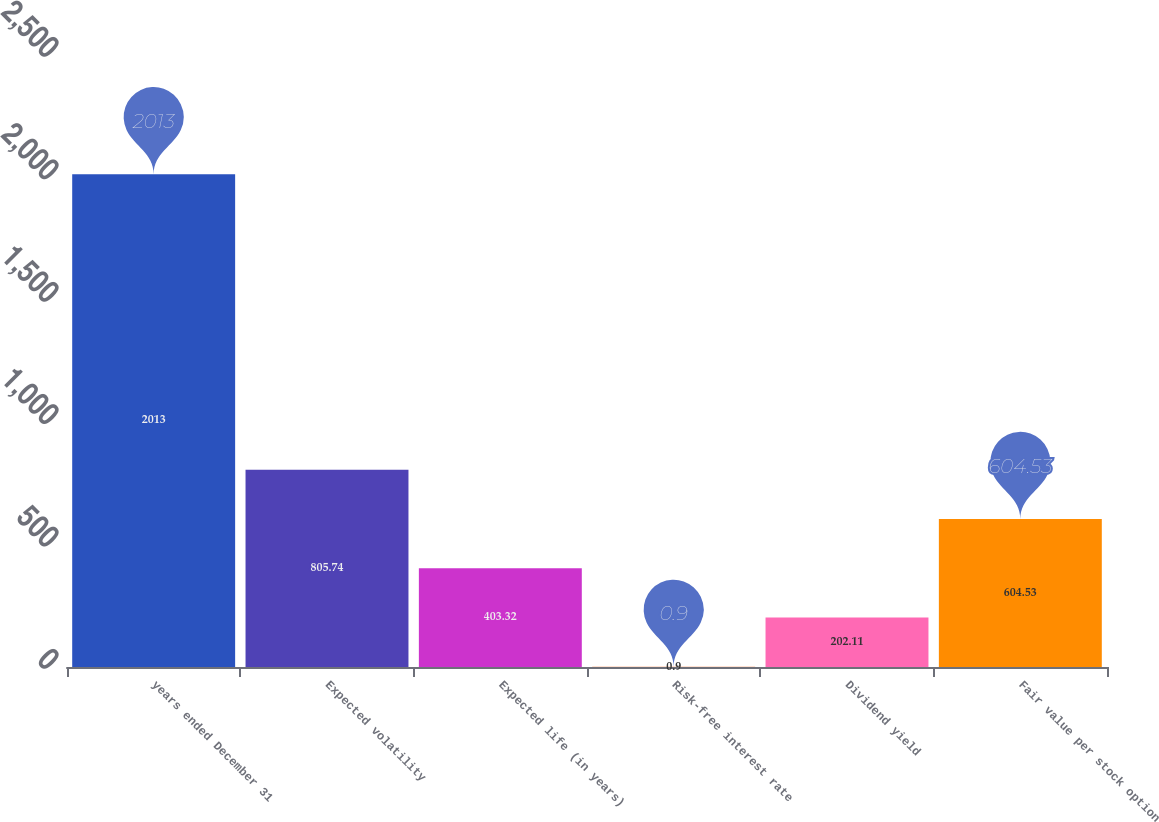Convert chart to OTSL. <chart><loc_0><loc_0><loc_500><loc_500><bar_chart><fcel>years ended December 31<fcel>Expected volatility<fcel>Expected life (in years)<fcel>Risk-free interest rate<fcel>Dividend yield<fcel>Fair value per stock option<nl><fcel>2013<fcel>805.74<fcel>403.32<fcel>0.9<fcel>202.11<fcel>604.53<nl></chart> 